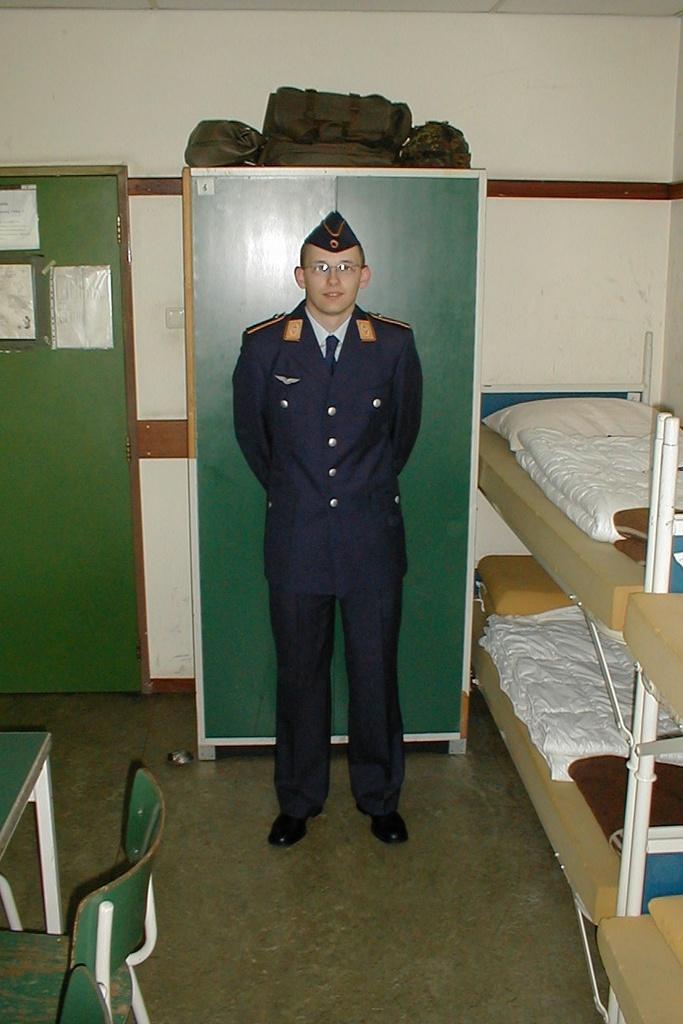Can you describe this image briefly? In the center of the image there is a person standing on the floor. Behind him there is a wardrobe. On top of it there are bags. Beside the wardrobe there are posters on the door. On the right side of the image there are beds. On top of it there are blankets and a pillow. On the left side of the image there are chairs. There is a table. In the background of the image there is a wall. 